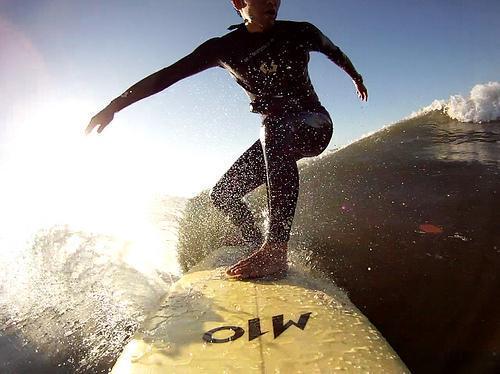How many people are there?
Give a very brief answer. 1. How many surfboards are there?
Give a very brief answer. 1. 